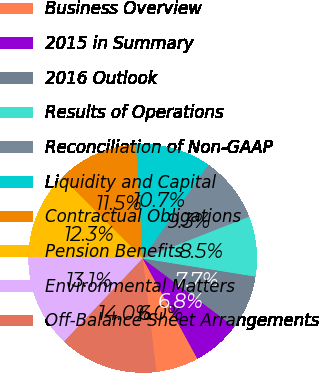Convert chart. <chart><loc_0><loc_0><loc_500><loc_500><pie_chart><fcel>Business Overview<fcel>2015 in Summary<fcel>2016 Outlook<fcel>Results of Operations<fcel>Reconciliation of Non-GAAP<fcel>Liquidity and Capital<fcel>Contractual Obligations<fcel>Pension Benefits<fcel>Environmental Matters<fcel>Off-Balance Sheet Arrangements<nl><fcel>6.03%<fcel>6.85%<fcel>7.67%<fcel>8.49%<fcel>9.32%<fcel>10.68%<fcel>11.51%<fcel>12.33%<fcel>13.15%<fcel>13.97%<nl></chart> 